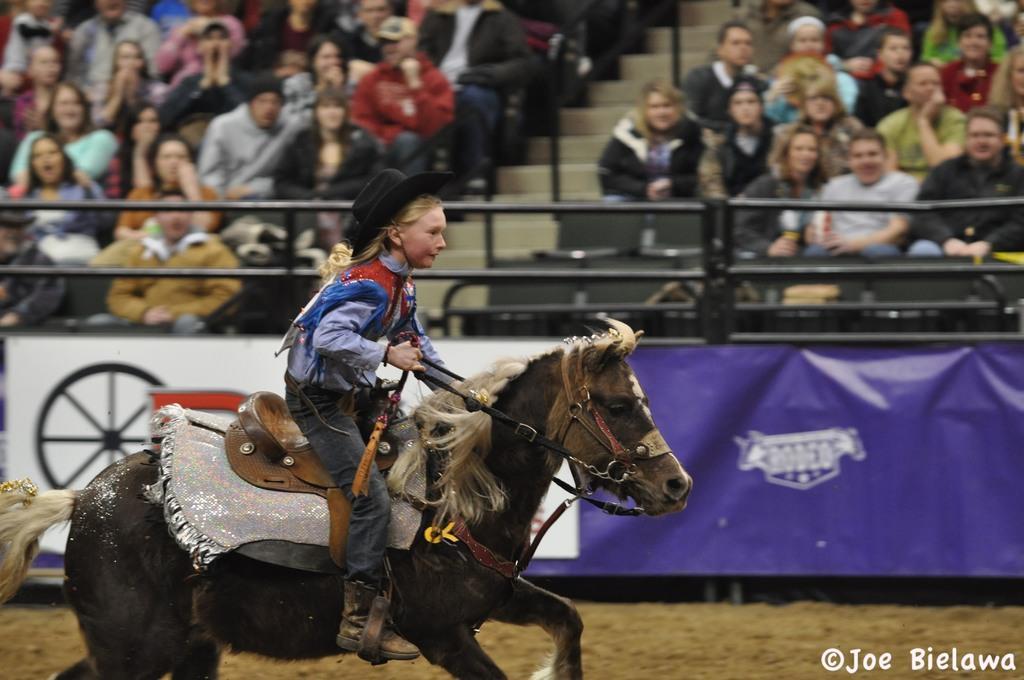Please provide a concise description of this image. Group of people sitting on the chair and this person riding on horse and wear hat. We can see steps,rods,banner and sand. 